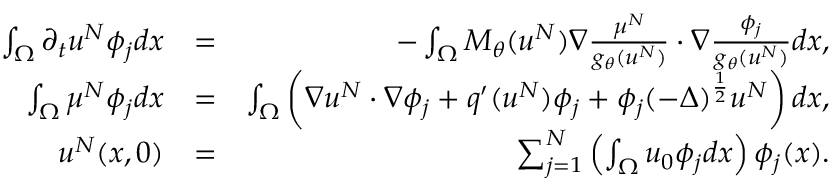<formula> <loc_0><loc_0><loc_500><loc_500>\begin{array} { r l r } { \int _ { \Omega } \partial _ { t } u ^ { N } \phi _ { j } d x } & { = } & { - \int _ { \Omega } M _ { \theta } ( u ^ { N } ) \nabla \frac { \mu ^ { N } } { g _ { \theta } ( u ^ { N } ) } \cdot \nabla \frac { \phi _ { j } } { g _ { \theta } ( u ^ { N } ) } d x , } \\ { \int _ { \Omega } \mu ^ { N } \phi _ { j } d x } & { = } & { \int _ { \Omega } \left ( \nabla u ^ { N } \cdot \nabla \phi _ { j } + q ^ { \prime } ( u ^ { N } ) \phi _ { j } + \phi _ { j } ( - \Delta ) ^ { \frac { 1 } { 2 } } u ^ { N } \right ) d x , } \\ { u ^ { N } ( x , 0 ) } & { = } & { \sum _ { j = 1 } ^ { N } \left ( \int _ { \Omega } u _ { 0 } \phi _ { j } d x \right ) \phi _ { j } ( x ) . } \end{array}</formula> 